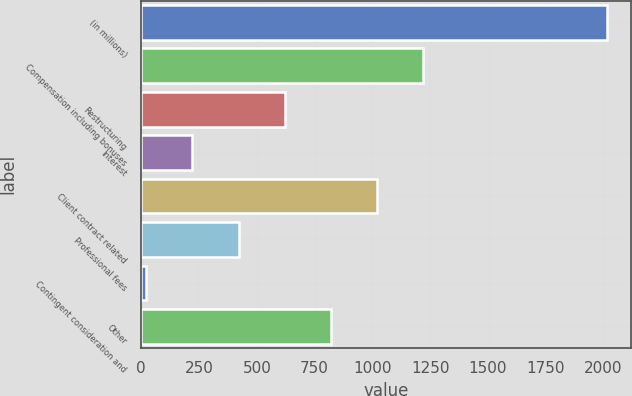Convert chart. <chart><loc_0><loc_0><loc_500><loc_500><bar_chart><fcel>(in millions)<fcel>Compensation including bonuses<fcel>Restructuring<fcel>Interest<fcel>Client contract related<fcel>Professional fees<fcel>Contingent consideration and<fcel>Other<nl><fcel>2016<fcel>1218.4<fcel>620.2<fcel>221.4<fcel>1019<fcel>420.8<fcel>22<fcel>819.6<nl></chart> 